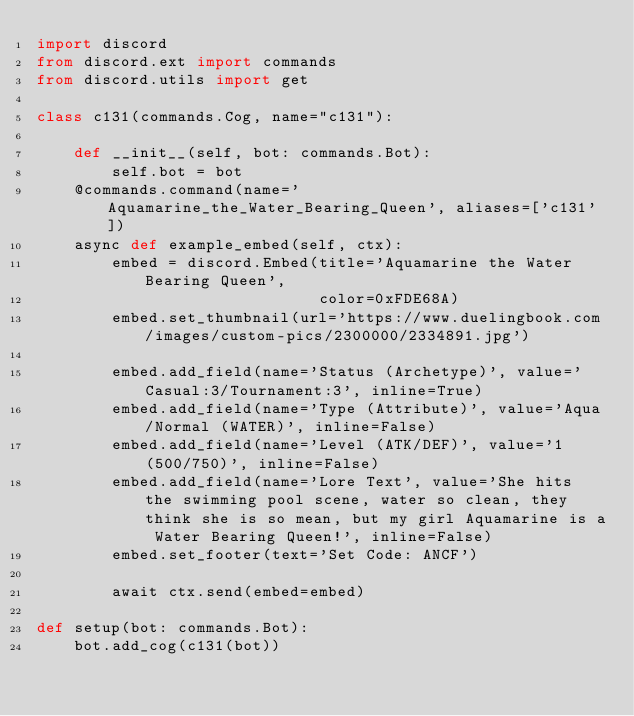<code> <loc_0><loc_0><loc_500><loc_500><_Python_>import discord
from discord.ext import commands
from discord.utils import get

class c131(commands.Cog, name="c131"):

    def __init__(self, bot: commands.Bot):
        self.bot = bot
    @commands.command(name='Aquamarine_the_Water_Bearing_Queen', aliases=['c131'])
    async def example_embed(self, ctx):
        embed = discord.Embed(title='Aquamarine the Water Bearing Queen',
                              color=0xFDE68A)
        embed.set_thumbnail(url='https://www.duelingbook.com/images/custom-pics/2300000/2334891.jpg')

        embed.add_field(name='Status (Archetype)', value='Casual:3/Tournament:3', inline=True)
        embed.add_field(name='Type (Attribute)', value='Aqua/Normal (WATER)', inline=False)
        embed.add_field(name='Level (ATK/DEF)', value='1 (500/750)', inline=False)
        embed.add_field(name='Lore Text', value='She hits the swimming pool scene, water so clean, they think she is so mean, but my girl Aquamarine is a Water Bearing Queen!', inline=False)
        embed.set_footer(text='Set Code: ANCF')

        await ctx.send(embed=embed)

def setup(bot: commands.Bot):
    bot.add_cog(c131(bot))</code> 